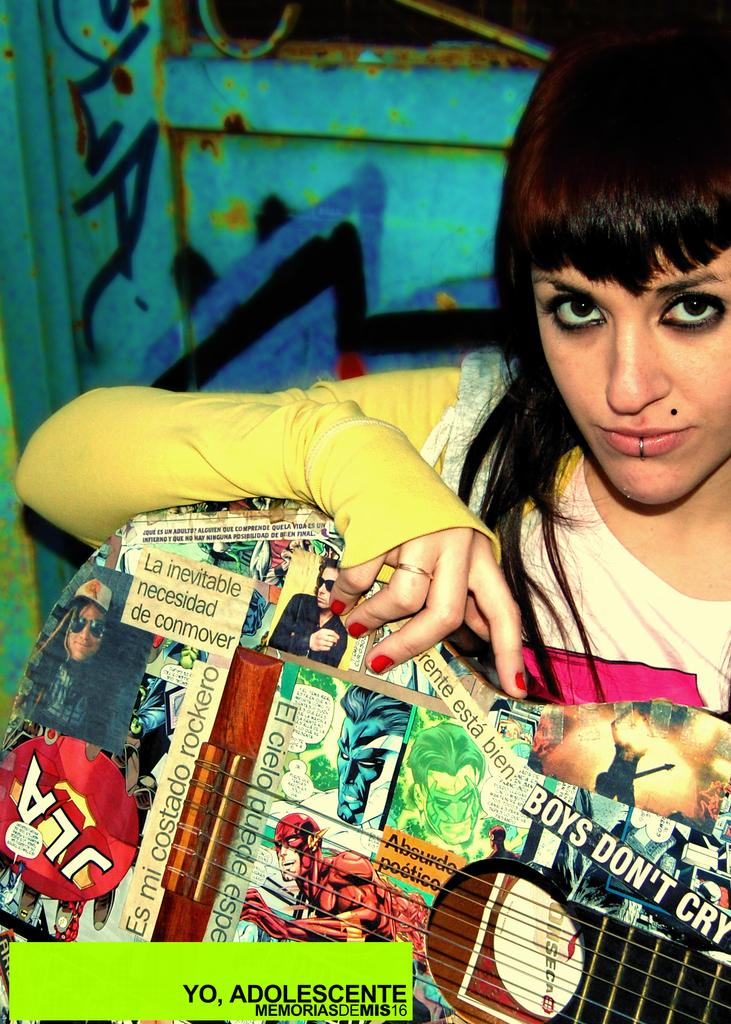<image>
Create a compact narrative representing the image presented. a girl holding a collection of comic books and boys dont cry bumper sticker 